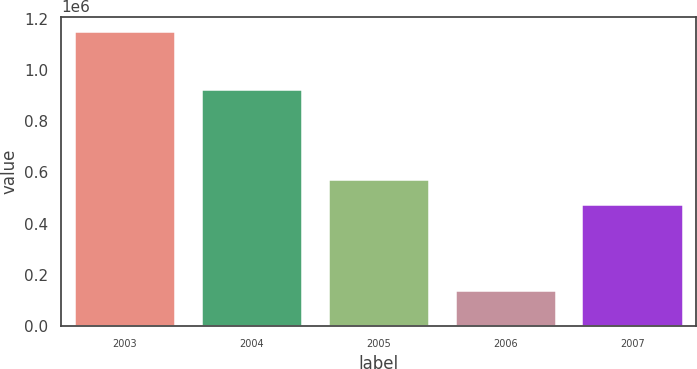Convert chart to OTSL. <chart><loc_0><loc_0><loc_500><loc_500><bar_chart><fcel>2003<fcel>2004<fcel>2005<fcel>2006<fcel>2007<nl><fcel>1.15079e+06<fcel>925005<fcel>576371<fcel>139952<fcel>475288<nl></chart> 